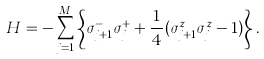Convert formula to latex. <formula><loc_0><loc_0><loc_500><loc_500>H = - \sum _ { j = 1 } ^ { M } \left \{ \sigma _ { j + 1 } ^ { - } \sigma _ { j } ^ { + } + \frac { 1 } { 4 } ( \sigma _ { j + 1 } ^ { z } \sigma _ { j } ^ { z } - 1 ) \right \} .</formula> 